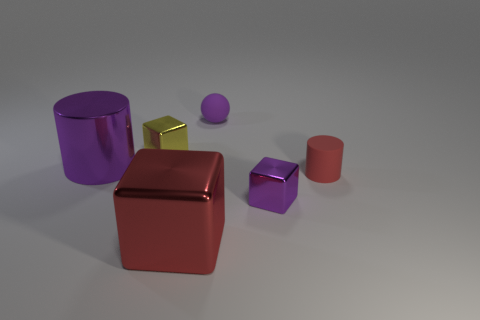Subtract all small metal cubes. How many cubes are left? 1 Add 1 large shiny cylinders. How many objects exist? 7 Subtract all cyan cubes. Subtract all cyan balls. How many cubes are left? 3 Subtract all balls. How many objects are left? 5 Add 5 metal cylinders. How many metal cylinders are left? 6 Add 4 large cyan shiny balls. How many large cyan shiny balls exist? 4 Subtract 0 yellow balls. How many objects are left? 6 Subtract all tiny rubber spheres. Subtract all purple matte objects. How many objects are left? 4 